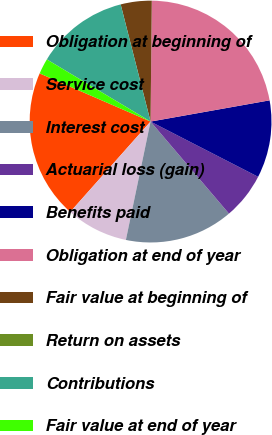Convert chart to OTSL. <chart><loc_0><loc_0><loc_500><loc_500><pie_chart><fcel>Obligation at beginning of<fcel>Service cost<fcel>Interest cost<fcel>Actuarial loss (gain)<fcel>Benefits paid<fcel>Obligation at end of year<fcel>Fair value at beginning of<fcel>Return on assets<fcel>Contributions<fcel>Fair value at end of year<nl><fcel>19.96%<fcel>8.29%<fcel>14.5%<fcel>6.22%<fcel>10.36%<fcel>22.03%<fcel>4.14%<fcel>0.0%<fcel>12.43%<fcel>2.07%<nl></chart> 